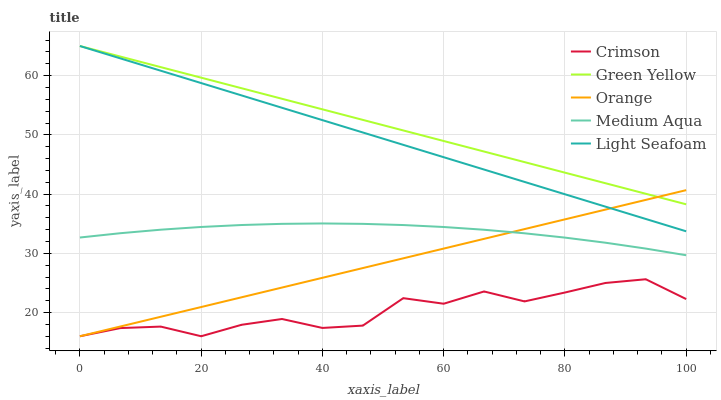Does Crimson have the minimum area under the curve?
Answer yes or no. Yes. Does Green Yellow have the maximum area under the curve?
Answer yes or no. Yes. Does Orange have the minimum area under the curve?
Answer yes or no. No. Does Orange have the maximum area under the curve?
Answer yes or no. No. Is Orange the smoothest?
Answer yes or no. Yes. Is Crimson the roughest?
Answer yes or no. Yes. Is Green Yellow the smoothest?
Answer yes or no. No. Is Green Yellow the roughest?
Answer yes or no. No. Does Crimson have the lowest value?
Answer yes or no. Yes. Does Green Yellow have the lowest value?
Answer yes or no. No. Does Light Seafoam have the highest value?
Answer yes or no. Yes. Does Orange have the highest value?
Answer yes or no. No. Is Crimson less than Green Yellow?
Answer yes or no. Yes. Is Green Yellow greater than Medium Aqua?
Answer yes or no. Yes. Does Medium Aqua intersect Orange?
Answer yes or no. Yes. Is Medium Aqua less than Orange?
Answer yes or no. No. Is Medium Aqua greater than Orange?
Answer yes or no. No. Does Crimson intersect Green Yellow?
Answer yes or no. No. 